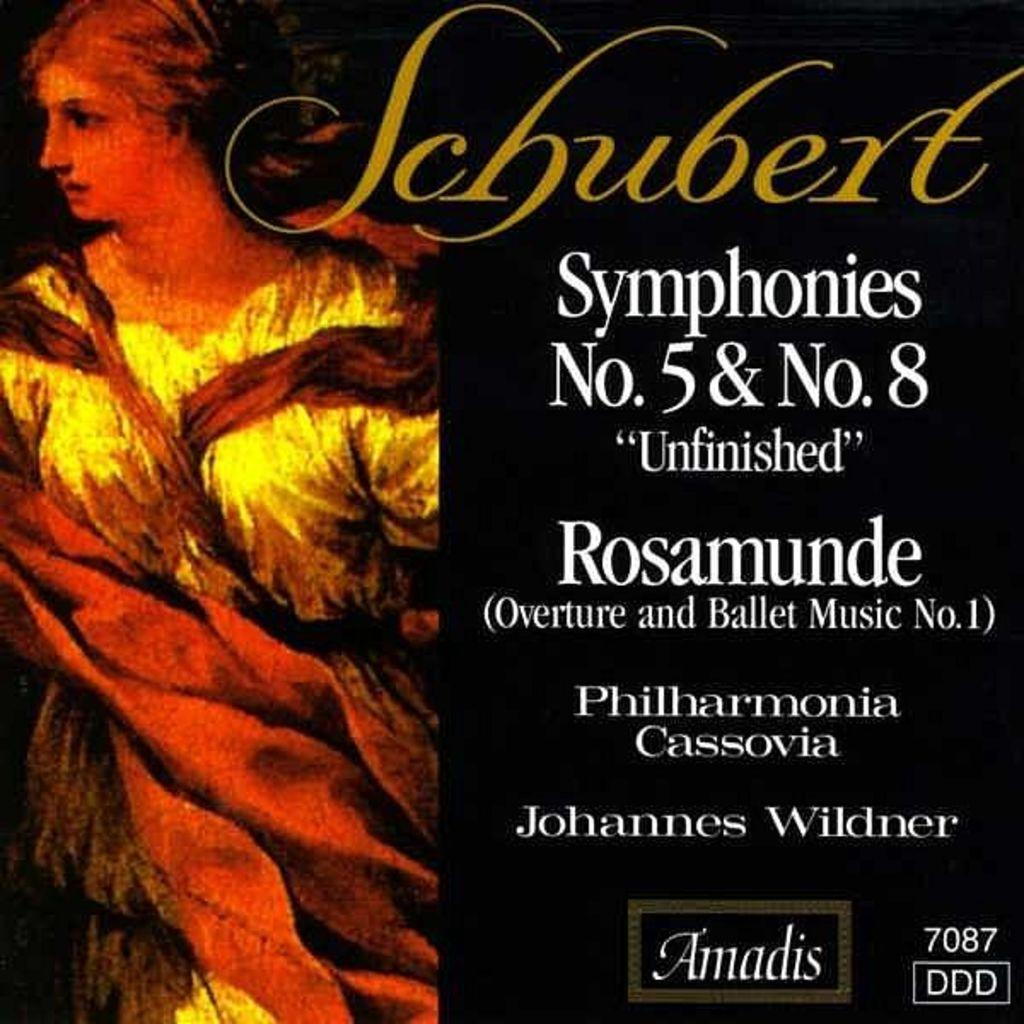<image>
Offer a succinct explanation of the picture presented. An album cover for Schubert Symphonies No. 5 & No. 8. 